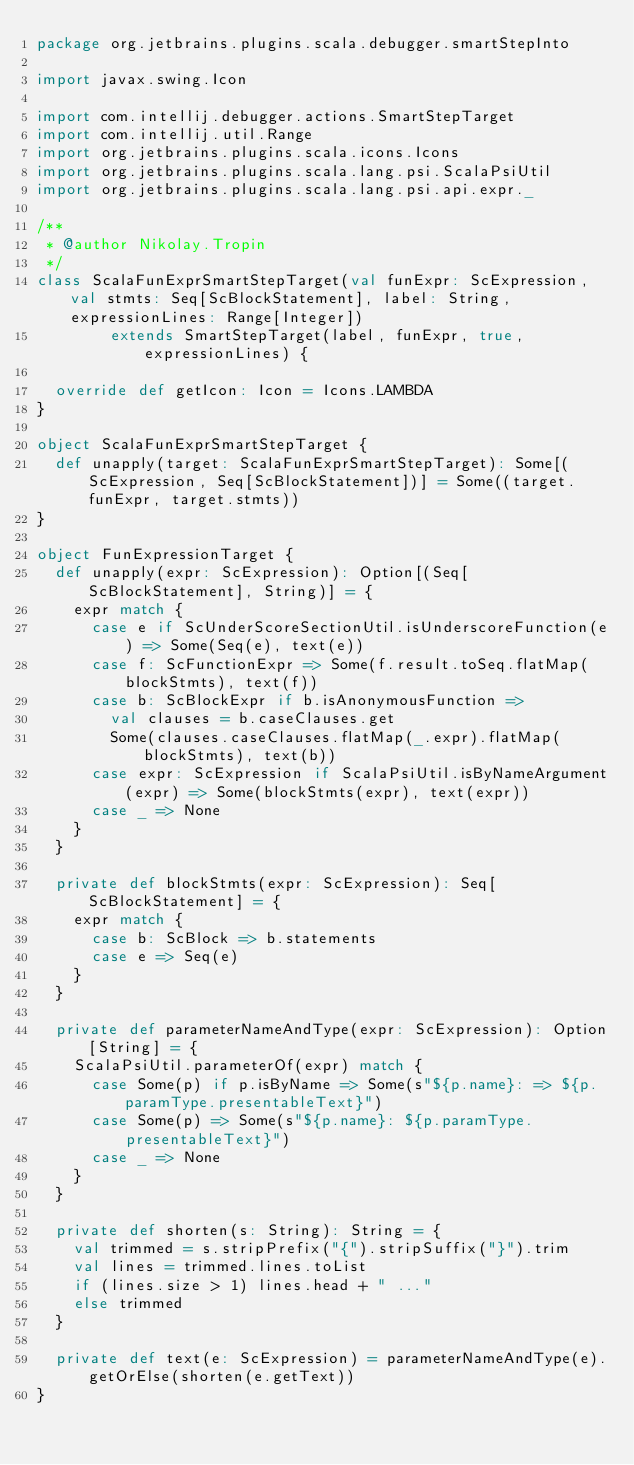Convert code to text. <code><loc_0><loc_0><loc_500><loc_500><_Scala_>package org.jetbrains.plugins.scala.debugger.smartStepInto

import javax.swing.Icon

import com.intellij.debugger.actions.SmartStepTarget
import com.intellij.util.Range
import org.jetbrains.plugins.scala.icons.Icons
import org.jetbrains.plugins.scala.lang.psi.ScalaPsiUtil
import org.jetbrains.plugins.scala.lang.psi.api.expr._

/**
 * @author Nikolay.Tropin
 */
class ScalaFunExprSmartStepTarget(val funExpr: ScExpression, val stmts: Seq[ScBlockStatement], label: String, expressionLines: Range[Integer])
        extends SmartStepTarget(label, funExpr, true, expressionLines) {

  override def getIcon: Icon = Icons.LAMBDA
}

object ScalaFunExprSmartStepTarget {
  def unapply(target: ScalaFunExprSmartStepTarget): Some[(ScExpression, Seq[ScBlockStatement])] = Some((target.funExpr, target.stmts))
}

object FunExpressionTarget {
  def unapply(expr: ScExpression): Option[(Seq[ScBlockStatement], String)] = {
    expr match {
      case e if ScUnderScoreSectionUtil.isUnderscoreFunction(e) => Some(Seq(e), text(e))
      case f: ScFunctionExpr => Some(f.result.toSeq.flatMap(blockStmts), text(f))
      case b: ScBlockExpr if b.isAnonymousFunction =>
        val clauses = b.caseClauses.get
        Some(clauses.caseClauses.flatMap(_.expr).flatMap(blockStmts), text(b))
      case expr: ScExpression if ScalaPsiUtil.isByNameArgument(expr) => Some(blockStmts(expr), text(expr))
      case _ => None
    }
  }

  private def blockStmts(expr: ScExpression): Seq[ScBlockStatement] = {
    expr match {
      case b: ScBlock => b.statements
      case e => Seq(e)
    }
  }

  private def parameterNameAndType(expr: ScExpression): Option[String] = {
    ScalaPsiUtil.parameterOf(expr) match {
      case Some(p) if p.isByName => Some(s"${p.name}: => ${p.paramType.presentableText}")
      case Some(p) => Some(s"${p.name}: ${p.paramType.presentableText}")
      case _ => None
    }
  }

  private def shorten(s: String): String = {
    val trimmed = s.stripPrefix("{").stripSuffix("}").trim
    val lines = trimmed.lines.toList
    if (lines.size > 1) lines.head + " ..."
    else trimmed
  }

  private def text(e: ScExpression) = parameterNameAndType(e).getOrElse(shorten(e.getText))
}</code> 